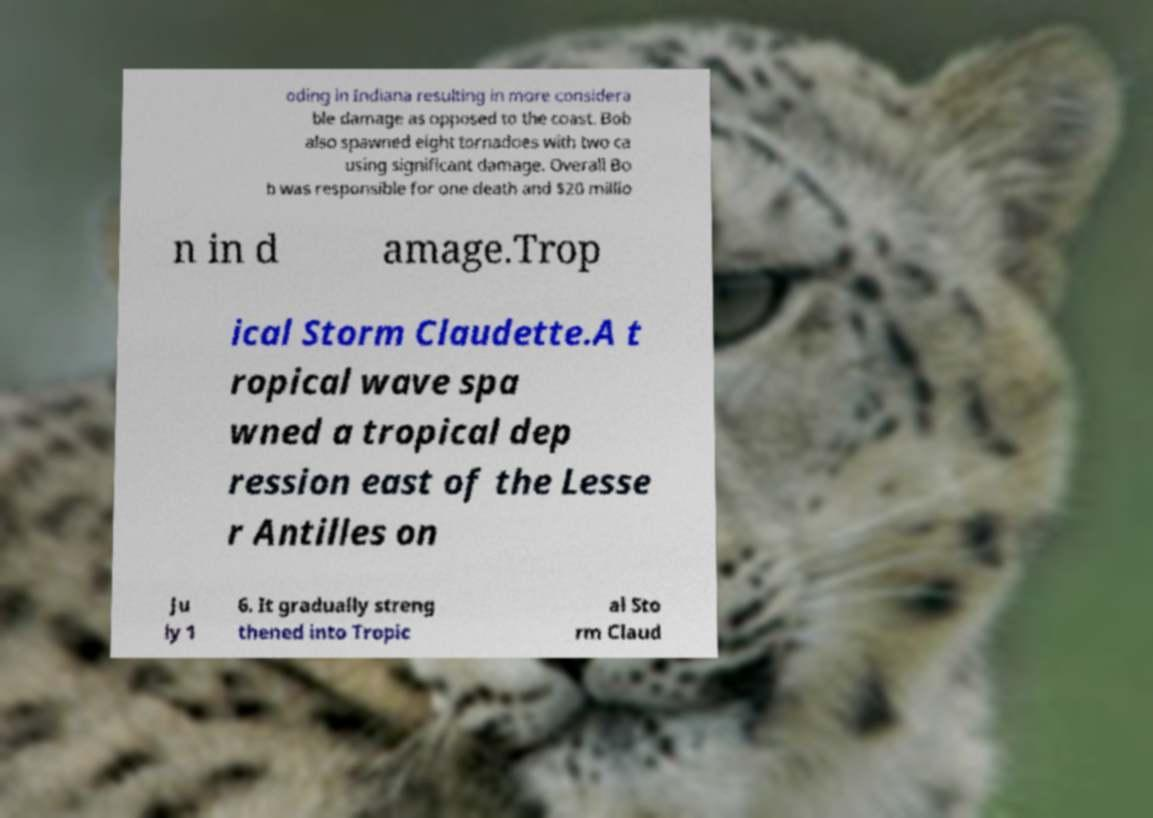Please identify and transcribe the text found in this image. oding in Indiana resulting in more considera ble damage as opposed to the coast. Bob also spawned eight tornadoes with two ca using significant damage. Overall Bo b was responsible for one death and $20 millio n in d amage.Trop ical Storm Claudette.A t ropical wave spa wned a tropical dep ression east of the Lesse r Antilles on Ju ly 1 6. It gradually streng thened into Tropic al Sto rm Claud 